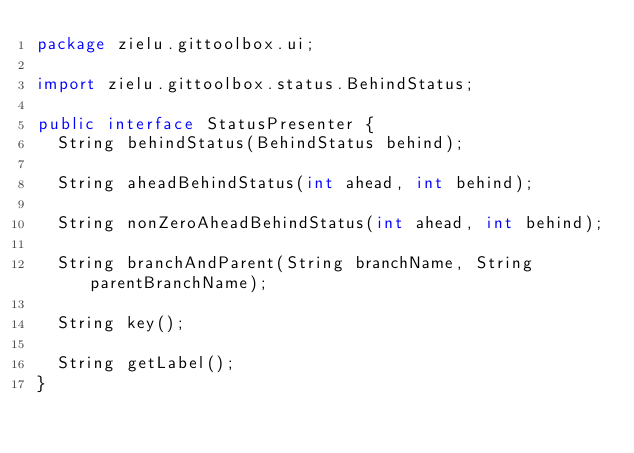<code> <loc_0><loc_0><loc_500><loc_500><_Java_>package zielu.gittoolbox.ui;

import zielu.gittoolbox.status.BehindStatus;

public interface StatusPresenter {
  String behindStatus(BehindStatus behind);

  String aheadBehindStatus(int ahead, int behind);

  String nonZeroAheadBehindStatus(int ahead, int behind);

  String branchAndParent(String branchName, String parentBranchName);

  String key();

  String getLabel();
}
</code> 